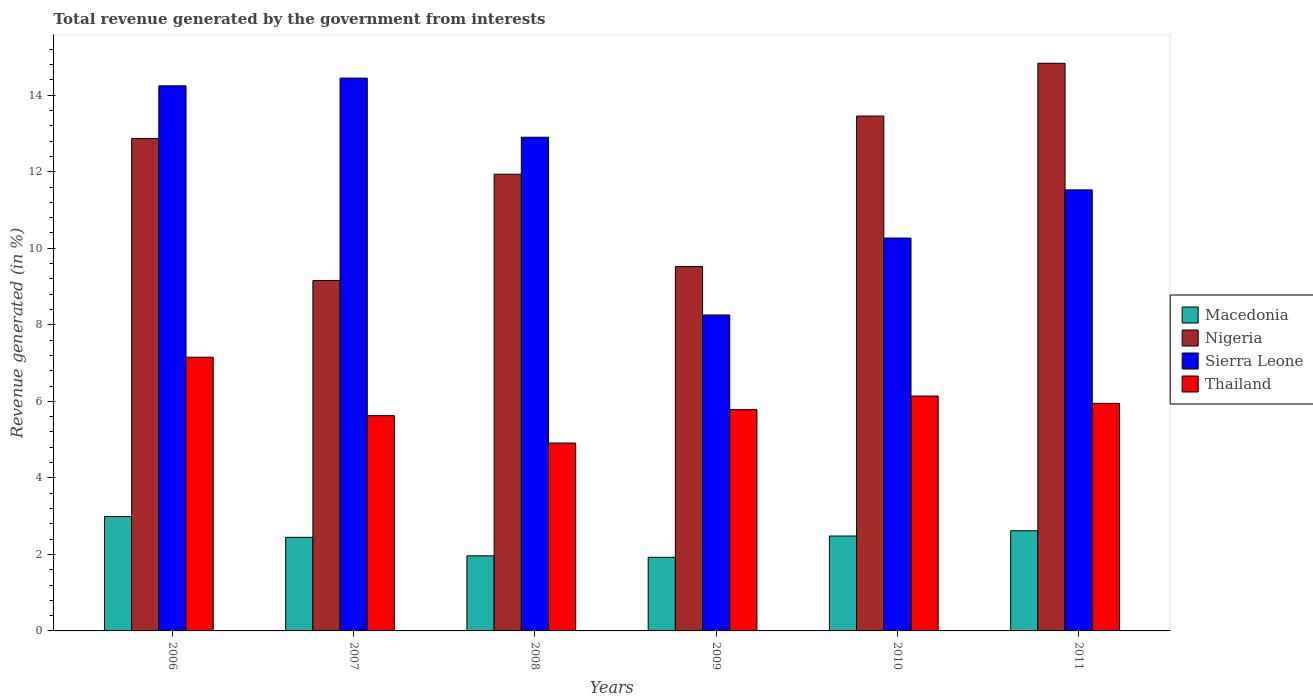How many different coloured bars are there?
Your answer should be compact. 4. Are the number of bars per tick equal to the number of legend labels?
Your answer should be compact. Yes. In how many cases, is the number of bars for a given year not equal to the number of legend labels?
Ensure brevity in your answer.  0. What is the total revenue generated in Nigeria in 2008?
Ensure brevity in your answer.  11.94. Across all years, what is the maximum total revenue generated in Nigeria?
Offer a very short reply. 14.84. Across all years, what is the minimum total revenue generated in Macedonia?
Ensure brevity in your answer.  1.92. In which year was the total revenue generated in Macedonia minimum?
Give a very brief answer. 2009. What is the total total revenue generated in Thailand in the graph?
Make the answer very short. 35.56. What is the difference between the total revenue generated in Sierra Leone in 2010 and that in 2011?
Give a very brief answer. -1.26. What is the difference between the total revenue generated in Macedonia in 2010 and the total revenue generated in Sierra Leone in 2009?
Offer a terse response. -5.78. What is the average total revenue generated in Nigeria per year?
Your response must be concise. 11.96. In the year 2011, what is the difference between the total revenue generated in Macedonia and total revenue generated in Sierra Leone?
Ensure brevity in your answer.  -8.91. What is the ratio of the total revenue generated in Macedonia in 2007 to that in 2011?
Offer a very short reply. 0.93. Is the total revenue generated in Macedonia in 2007 less than that in 2010?
Offer a very short reply. Yes. What is the difference between the highest and the second highest total revenue generated in Macedonia?
Provide a succinct answer. 0.37. What is the difference between the highest and the lowest total revenue generated in Macedonia?
Your response must be concise. 1.07. Is it the case that in every year, the sum of the total revenue generated in Thailand and total revenue generated in Nigeria is greater than the sum of total revenue generated in Sierra Leone and total revenue generated in Macedonia?
Offer a very short reply. No. What does the 4th bar from the left in 2011 represents?
Provide a short and direct response. Thailand. What does the 1st bar from the right in 2011 represents?
Offer a very short reply. Thailand. Is it the case that in every year, the sum of the total revenue generated in Macedonia and total revenue generated in Nigeria is greater than the total revenue generated in Sierra Leone?
Ensure brevity in your answer.  No. Are all the bars in the graph horizontal?
Offer a terse response. No. How many years are there in the graph?
Make the answer very short. 6. What is the difference between two consecutive major ticks on the Y-axis?
Your response must be concise. 2. Where does the legend appear in the graph?
Give a very brief answer. Center right. What is the title of the graph?
Provide a short and direct response. Total revenue generated by the government from interests. What is the label or title of the X-axis?
Give a very brief answer. Years. What is the label or title of the Y-axis?
Keep it short and to the point. Revenue generated (in %). What is the Revenue generated (in %) of Macedonia in 2006?
Your response must be concise. 2.99. What is the Revenue generated (in %) of Nigeria in 2006?
Offer a very short reply. 12.87. What is the Revenue generated (in %) of Sierra Leone in 2006?
Your answer should be compact. 14.25. What is the Revenue generated (in %) in Thailand in 2006?
Make the answer very short. 7.15. What is the Revenue generated (in %) in Macedonia in 2007?
Make the answer very short. 2.45. What is the Revenue generated (in %) of Nigeria in 2007?
Provide a succinct answer. 9.16. What is the Revenue generated (in %) of Sierra Leone in 2007?
Provide a succinct answer. 14.45. What is the Revenue generated (in %) in Thailand in 2007?
Offer a very short reply. 5.63. What is the Revenue generated (in %) of Macedonia in 2008?
Keep it short and to the point. 1.96. What is the Revenue generated (in %) of Nigeria in 2008?
Give a very brief answer. 11.94. What is the Revenue generated (in %) in Sierra Leone in 2008?
Offer a very short reply. 12.9. What is the Revenue generated (in %) in Thailand in 2008?
Make the answer very short. 4.91. What is the Revenue generated (in %) of Macedonia in 2009?
Keep it short and to the point. 1.92. What is the Revenue generated (in %) in Nigeria in 2009?
Provide a short and direct response. 9.52. What is the Revenue generated (in %) in Sierra Leone in 2009?
Provide a short and direct response. 8.26. What is the Revenue generated (in %) in Thailand in 2009?
Your answer should be very brief. 5.78. What is the Revenue generated (in %) of Macedonia in 2010?
Provide a succinct answer. 2.48. What is the Revenue generated (in %) in Nigeria in 2010?
Your answer should be compact. 13.46. What is the Revenue generated (in %) of Sierra Leone in 2010?
Your answer should be compact. 10.27. What is the Revenue generated (in %) in Thailand in 2010?
Make the answer very short. 6.14. What is the Revenue generated (in %) in Macedonia in 2011?
Give a very brief answer. 2.62. What is the Revenue generated (in %) in Nigeria in 2011?
Your answer should be compact. 14.84. What is the Revenue generated (in %) in Sierra Leone in 2011?
Your answer should be very brief. 11.53. What is the Revenue generated (in %) of Thailand in 2011?
Offer a very short reply. 5.95. Across all years, what is the maximum Revenue generated (in %) of Macedonia?
Your response must be concise. 2.99. Across all years, what is the maximum Revenue generated (in %) in Nigeria?
Your response must be concise. 14.84. Across all years, what is the maximum Revenue generated (in %) in Sierra Leone?
Give a very brief answer. 14.45. Across all years, what is the maximum Revenue generated (in %) of Thailand?
Keep it short and to the point. 7.15. Across all years, what is the minimum Revenue generated (in %) in Macedonia?
Keep it short and to the point. 1.92. Across all years, what is the minimum Revenue generated (in %) of Nigeria?
Provide a succinct answer. 9.16. Across all years, what is the minimum Revenue generated (in %) of Sierra Leone?
Keep it short and to the point. 8.26. Across all years, what is the minimum Revenue generated (in %) in Thailand?
Provide a short and direct response. 4.91. What is the total Revenue generated (in %) in Macedonia in the graph?
Your answer should be very brief. 14.42. What is the total Revenue generated (in %) of Nigeria in the graph?
Your answer should be very brief. 71.78. What is the total Revenue generated (in %) in Sierra Leone in the graph?
Offer a very short reply. 71.65. What is the total Revenue generated (in %) of Thailand in the graph?
Your answer should be compact. 35.56. What is the difference between the Revenue generated (in %) of Macedonia in 2006 and that in 2007?
Your answer should be compact. 0.54. What is the difference between the Revenue generated (in %) in Nigeria in 2006 and that in 2007?
Offer a very short reply. 3.71. What is the difference between the Revenue generated (in %) in Sierra Leone in 2006 and that in 2007?
Offer a very short reply. -0.2. What is the difference between the Revenue generated (in %) in Thailand in 2006 and that in 2007?
Ensure brevity in your answer.  1.53. What is the difference between the Revenue generated (in %) of Macedonia in 2006 and that in 2008?
Keep it short and to the point. 1.03. What is the difference between the Revenue generated (in %) of Nigeria in 2006 and that in 2008?
Give a very brief answer. 0.93. What is the difference between the Revenue generated (in %) of Sierra Leone in 2006 and that in 2008?
Make the answer very short. 1.34. What is the difference between the Revenue generated (in %) in Thailand in 2006 and that in 2008?
Provide a short and direct response. 2.24. What is the difference between the Revenue generated (in %) in Macedonia in 2006 and that in 2009?
Provide a succinct answer. 1.07. What is the difference between the Revenue generated (in %) in Nigeria in 2006 and that in 2009?
Provide a short and direct response. 3.35. What is the difference between the Revenue generated (in %) in Sierra Leone in 2006 and that in 2009?
Offer a terse response. 5.99. What is the difference between the Revenue generated (in %) of Thailand in 2006 and that in 2009?
Provide a short and direct response. 1.37. What is the difference between the Revenue generated (in %) in Macedonia in 2006 and that in 2010?
Make the answer very short. 0.51. What is the difference between the Revenue generated (in %) in Nigeria in 2006 and that in 2010?
Give a very brief answer. -0.59. What is the difference between the Revenue generated (in %) of Sierra Leone in 2006 and that in 2010?
Make the answer very short. 3.98. What is the difference between the Revenue generated (in %) in Thailand in 2006 and that in 2010?
Keep it short and to the point. 1.02. What is the difference between the Revenue generated (in %) in Macedonia in 2006 and that in 2011?
Offer a terse response. 0.37. What is the difference between the Revenue generated (in %) of Nigeria in 2006 and that in 2011?
Provide a succinct answer. -1.97. What is the difference between the Revenue generated (in %) of Sierra Leone in 2006 and that in 2011?
Offer a very short reply. 2.72. What is the difference between the Revenue generated (in %) in Thailand in 2006 and that in 2011?
Keep it short and to the point. 1.21. What is the difference between the Revenue generated (in %) of Macedonia in 2007 and that in 2008?
Give a very brief answer. 0.48. What is the difference between the Revenue generated (in %) of Nigeria in 2007 and that in 2008?
Your response must be concise. -2.78. What is the difference between the Revenue generated (in %) of Sierra Leone in 2007 and that in 2008?
Offer a terse response. 1.55. What is the difference between the Revenue generated (in %) in Thailand in 2007 and that in 2008?
Provide a succinct answer. 0.72. What is the difference between the Revenue generated (in %) of Macedonia in 2007 and that in 2009?
Give a very brief answer. 0.52. What is the difference between the Revenue generated (in %) of Nigeria in 2007 and that in 2009?
Your response must be concise. -0.37. What is the difference between the Revenue generated (in %) of Sierra Leone in 2007 and that in 2009?
Offer a terse response. 6.19. What is the difference between the Revenue generated (in %) of Thailand in 2007 and that in 2009?
Offer a terse response. -0.16. What is the difference between the Revenue generated (in %) in Macedonia in 2007 and that in 2010?
Offer a very short reply. -0.03. What is the difference between the Revenue generated (in %) of Nigeria in 2007 and that in 2010?
Make the answer very short. -4.3. What is the difference between the Revenue generated (in %) in Sierra Leone in 2007 and that in 2010?
Keep it short and to the point. 4.18. What is the difference between the Revenue generated (in %) of Thailand in 2007 and that in 2010?
Provide a short and direct response. -0.51. What is the difference between the Revenue generated (in %) in Macedonia in 2007 and that in 2011?
Ensure brevity in your answer.  -0.17. What is the difference between the Revenue generated (in %) in Nigeria in 2007 and that in 2011?
Offer a very short reply. -5.68. What is the difference between the Revenue generated (in %) in Sierra Leone in 2007 and that in 2011?
Make the answer very short. 2.92. What is the difference between the Revenue generated (in %) in Thailand in 2007 and that in 2011?
Provide a succinct answer. -0.32. What is the difference between the Revenue generated (in %) of Macedonia in 2008 and that in 2009?
Offer a very short reply. 0.04. What is the difference between the Revenue generated (in %) of Nigeria in 2008 and that in 2009?
Your response must be concise. 2.41. What is the difference between the Revenue generated (in %) of Sierra Leone in 2008 and that in 2009?
Ensure brevity in your answer.  4.65. What is the difference between the Revenue generated (in %) in Thailand in 2008 and that in 2009?
Your answer should be compact. -0.87. What is the difference between the Revenue generated (in %) in Macedonia in 2008 and that in 2010?
Ensure brevity in your answer.  -0.52. What is the difference between the Revenue generated (in %) of Nigeria in 2008 and that in 2010?
Provide a short and direct response. -1.52. What is the difference between the Revenue generated (in %) of Sierra Leone in 2008 and that in 2010?
Make the answer very short. 2.63. What is the difference between the Revenue generated (in %) of Thailand in 2008 and that in 2010?
Keep it short and to the point. -1.23. What is the difference between the Revenue generated (in %) of Macedonia in 2008 and that in 2011?
Your answer should be compact. -0.66. What is the difference between the Revenue generated (in %) of Nigeria in 2008 and that in 2011?
Your answer should be compact. -2.9. What is the difference between the Revenue generated (in %) in Sierra Leone in 2008 and that in 2011?
Ensure brevity in your answer.  1.38. What is the difference between the Revenue generated (in %) of Thailand in 2008 and that in 2011?
Provide a succinct answer. -1.04. What is the difference between the Revenue generated (in %) of Macedonia in 2009 and that in 2010?
Make the answer very short. -0.56. What is the difference between the Revenue generated (in %) of Nigeria in 2009 and that in 2010?
Ensure brevity in your answer.  -3.93. What is the difference between the Revenue generated (in %) in Sierra Leone in 2009 and that in 2010?
Keep it short and to the point. -2.01. What is the difference between the Revenue generated (in %) of Thailand in 2009 and that in 2010?
Your answer should be very brief. -0.36. What is the difference between the Revenue generated (in %) in Macedonia in 2009 and that in 2011?
Give a very brief answer. -0.69. What is the difference between the Revenue generated (in %) of Nigeria in 2009 and that in 2011?
Your answer should be compact. -5.31. What is the difference between the Revenue generated (in %) of Sierra Leone in 2009 and that in 2011?
Provide a succinct answer. -3.27. What is the difference between the Revenue generated (in %) of Thailand in 2009 and that in 2011?
Keep it short and to the point. -0.17. What is the difference between the Revenue generated (in %) in Macedonia in 2010 and that in 2011?
Make the answer very short. -0.14. What is the difference between the Revenue generated (in %) in Nigeria in 2010 and that in 2011?
Make the answer very short. -1.38. What is the difference between the Revenue generated (in %) of Sierra Leone in 2010 and that in 2011?
Your response must be concise. -1.26. What is the difference between the Revenue generated (in %) of Thailand in 2010 and that in 2011?
Ensure brevity in your answer.  0.19. What is the difference between the Revenue generated (in %) of Macedonia in 2006 and the Revenue generated (in %) of Nigeria in 2007?
Provide a short and direct response. -6.17. What is the difference between the Revenue generated (in %) of Macedonia in 2006 and the Revenue generated (in %) of Sierra Leone in 2007?
Your answer should be compact. -11.46. What is the difference between the Revenue generated (in %) of Macedonia in 2006 and the Revenue generated (in %) of Thailand in 2007?
Keep it short and to the point. -2.64. What is the difference between the Revenue generated (in %) in Nigeria in 2006 and the Revenue generated (in %) in Sierra Leone in 2007?
Offer a very short reply. -1.58. What is the difference between the Revenue generated (in %) of Nigeria in 2006 and the Revenue generated (in %) of Thailand in 2007?
Ensure brevity in your answer.  7.24. What is the difference between the Revenue generated (in %) in Sierra Leone in 2006 and the Revenue generated (in %) in Thailand in 2007?
Keep it short and to the point. 8.62. What is the difference between the Revenue generated (in %) in Macedonia in 2006 and the Revenue generated (in %) in Nigeria in 2008?
Offer a very short reply. -8.95. What is the difference between the Revenue generated (in %) in Macedonia in 2006 and the Revenue generated (in %) in Sierra Leone in 2008?
Ensure brevity in your answer.  -9.91. What is the difference between the Revenue generated (in %) of Macedonia in 2006 and the Revenue generated (in %) of Thailand in 2008?
Make the answer very short. -1.92. What is the difference between the Revenue generated (in %) of Nigeria in 2006 and the Revenue generated (in %) of Sierra Leone in 2008?
Make the answer very short. -0.03. What is the difference between the Revenue generated (in %) of Nigeria in 2006 and the Revenue generated (in %) of Thailand in 2008?
Offer a very short reply. 7.96. What is the difference between the Revenue generated (in %) of Sierra Leone in 2006 and the Revenue generated (in %) of Thailand in 2008?
Ensure brevity in your answer.  9.34. What is the difference between the Revenue generated (in %) of Macedonia in 2006 and the Revenue generated (in %) of Nigeria in 2009?
Your answer should be very brief. -6.53. What is the difference between the Revenue generated (in %) in Macedonia in 2006 and the Revenue generated (in %) in Sierra Leone in 2009?
Offer a very short reply. -5.27. What is the difference between the Revenue generated (in %) of Macedonia in 2006 and the Revenue generated (in %) of Thailand in 2009?
Ensure brevity in your answer.  -2.79. What is the difference between the Revenue generated (in %) in Nigeria in 2006 and the Revenue generated (in %) in Sierra Leone in 2009?
Offer a very short reply. 4.61. What is the difference between the Revenue generated (in %) in Nigeria in 2006 and the Revenue generated (in %) in Thailand in 2009?
Provide a short and direct response. 7.09. What is the difference between the Revenue generated (in %) in Sierra Leone in 2006 and the Revenue generated (in %) in Thailand in 2009?
Provide a short and direct response. 8.46. What is the difference between the Revenue generated (in %) of Macedonia in 2006 and the Revenue generated (in %) of Nigeria in 2010?
Give a very brief answer. -10.47. What is the difference between the Revenue generated (in %) in Macedonia in 2006 and the Revenue generated (in %) in Sierra Leone in 2010?
Ensure brevity in your answer.  -7.28. What is the difference between the Revenue generated (in %) of Macedonia in 2006 and the Revenue generated (in %) of Thailand in 2010?
Provide a short and direct response. -3.15. What is the difference between the Revenue generated (in %) in Nigeria in 2006 and the Revenue generated (in %) in Sierra Leone in 2010?
Provide a succinct answer. 2.6. What is the difference between the Revenue generated (in %) in Nigeria in 2006 and the Revenue generated (in %) in Thailand in 2010?
Your response must be concise. 6.73. What is the difference between the Revenue generated (in %) in Sierra Leone in 2006 and the Revenue generated (in %) in Thailand in 2010?
Provide a succinct answer. 8.11. What is the difference between the Revenue generated (in %) in Macedonia in 2006 and the Revenue generated (in %) in Nigeria in 2011?
Provide a succinct answer. -11.85. What is the difference between the Revenue generated (in %) of Macedonia in 2006 and the Revenue generated (in %) of Sierra Leone in 2011?
Provide a short and direct response. -8.54. What is the difference between the Revenue generated (in %) of Macedonia in 2006 and the Revenue generated (in %) of Thailand in 2011?
Ensure brevity in your answer.  -2.96. What is the difference between the Revenue generated (in %) in Nigeria in 2006 and the Revenue generated (in %) in Sierra Leone in 2011?
Offer a very short reply. 1.34. What is the difference between the Revenue generated (in %) in Nigeria in 2006 and the Revenue generated (in %) in Thailand in 2011?
Offer a terse response. 6.92. What is the difference between the Revenue generated (in %) of Sierra Leone in 2006 and the Revenue generated (in %) of Thailand in 2011?
Ensure brevity in your answer.  8.3. What is the difference between the Revenue generated (in %) in Macedonia in 2007 and the Revenue generated (in %) in Nigeria in 2008?
Ensure brevity in your answer.  -9.49. What is the difference between the Revenue generated (in %) in Macedonia in 2007 and the Revenue generated (in %) in Sierra Leone in 2008?
Ensure brevity in your answer.  -10.46. What is the difference between the Revenue generated (in %) in Macedonia in 2007 and the Revenue generated (in %) in Thailand in 2008?
Provide a succinct answer. -2.46. What is the difference between the Revenue generated (in %) of Nigeria in 2007 and the Revenue generated (in %) of Sierra Leone in 2008?
Provide a succinct answer. -3.75. What is the difference between the Revenue generated (in %) of Nigeria in 2007 and the Revenue generated (in %) of Thailand in 2008?
Your answer should be compact. 4.25. What is the difference between the Revenue generated (in %) in Sierra Leone in 2007 and the Revenue generated (in %) in Thailand in 2008?
Provide a short and direct response. 9.54. What is the difference between the Revenue generated (in %) of Macedonia in 2007 and the Revenue generated (in %) of Nigeria in 2009?
Ensure brevity in your answer.  -7.08. What is the difference between the Revenue generated (in %) of Macedonia in 2007 and the Revenue generated (in %) of Sierra Leone in 2009?
Keep it short and to the point. -5.81. What is the difference between the Revenue generated (in %) of Macedonia in 2007 and the Revenue generated (in %) of Thailand in 2009?
Offer a terse response. -3.34. What is the difference between the Revenue generated (in %) in Nigeria in 2007 and the Revenue generated (in %) in Sierra Leone in 2009?
Keep it short and to the point. 0.9. What is the difference between the Revenue generated (in %) in Nigeria in 2007 and the Revenue generated (in %) in Thailand in 2009?
Your answer should be compact. 3.37. What is the difference between the Revenue generated (in %) of Sierra Leone in 2007 and the Revenue generated (in %) of Thailand in 2009?
Make the answer very short. 8.67. What is the difference between the Revenue generated (in %) in Macedonia in 2007 and the Revenue generated (in %) in Nigeria in 2010?
Your answer should be very brief. -11.01. What is the difference between the Revenue generated (in %) of Macedonia in 2007 and the Revenue generated (in %) of Sierra Leone in 2010?
Ensure brevity in your answer.  -7.82. What is the difference between the Revenue generated (in %) of Macedonia in 2007 and the Revenue generated (in %) of Thailand in 2010?
Your response must be concise. -3.69. What is the difference between the Revenue generated (in %) in Nigeria in 2007 and the Revenue generated (in %) in Sierra Leone in 2010?
Ensure brevity in your answer.  -1.11. What is the difference between the Revenue generated (in %) of Nigeria in 2007 and the Revenue generated (in %) of Thailand in 2010?
Provide a succinct answer. 3.02. What is the difference between the Revenue generated (in %) of Sierra Leone in 2007 and the Revenue generated (in %) of Thailand in 2010?
Provide a succinct answer. 8.31. What is the difference between the Revenue generated (in %) in Macedonia in 2007 and the Revenue generated (in %) in Nigeria in 2011?
Offer a terse response. -12.39. What is the difference between the Revenue generated (in %) of Macedonia in 2007 and the Revenue generated (in %) of Sierra Leone in 2011?
Offer a very short reply. -9.08. What is the difference between the Revenue generated (in %) in Macedonia in 2007 and the Revenue generated (in %) in Thailand in 2011?
Keep it short and to the point. -3.5. What is the difference between the Revenue generated (in %) of Nigeria in 2007 and the Revenue generated (in %) of Sierra Leone in 2011?
Your response must be concise. -2.37. What is the difference between the Revenue generated (in %) of Nigeria in 2007 and the Revenue generated (in %) of Thailand in 2011?
Provide a short and direct response. 3.21. What is the difference between the Revenue generated (in %) of Sierra Leone in 2007 and the Revenue generated (in %) of Thailand in 2011?
Give a very brief answer. 8.5. What is the difference between the Revenue generated (in %) of Macedonia in 2008 and the Revenue generated (in %) of Nigeria in 2009?
Ensure brevity in your answer.  -7.56. What is the difference between the Revenue generated (in %) of Macedonia in 2008 and the Revenue generated (in %) of Sierra Leone in 2009?
Give a very brief answer. -6.29. What is the difference between the Revenue generated (in %) of Macedonia in 2008 and the Revenue generated (in %) of Thailand in 2009?
Give a very brief answer. -3.82. What is the difference between the Revenue generated (in %) of Nigeria in 2008 and the Revenue generated (in %) of Sierra Leone in 2009?
Ensure brevity in your answer.  3.68. What is the difference between the Revenue generated (in %) of Nigeria in 2008 and the Revenue generated (in %) of Thailand in 2009?
Your response must be concise. 6.15. What is the difference between the Revenue generated (in %) in Sierra Leone in 2008 and the Revenue generated (in %) in Thailand in 2009?
Give a very brief answer. 7.12. What is the difference between the Revenue generated (in %) of Macedonia in 2008 and the Revenue generated (in %) of Nigeria in 2010?
Provide a short and direct response. -11.49. What is the difference between the Revenue generated (in %) of Macedonia in 2008 and the Revenue generated (in %) of Sierra Leone in 2010?
Offer a very short reply. -8.31. What is the difference between the Revenue generated (in %) of Macedonia in 2008 and the Revenue generated (in %) of Thailand in 2010?
Give a very brief answer. -4.18. What is the difference between the Revenue generated (in %) in Nigeria in 2008 and the Revenue generated (in %) in Sierra Leone in 2010?
Provide a short and direct response. 1.67. What is the difference between the Revenue generated (in %) in Nigeria in 2008 and the Revenue generated (in %) in Thailand in 2010?
Provide a succinct answer. 5.8. What is the difference between the Revenue generated (in %) of Sierra Leone in 2008 and the Revenue generated (in %) of Thailand in 2010?
Provide a succinct answer. 6.76. What is the difference between the Revenue generated (in %) of Macedonia in 2008 and the Revenue generated (in %) of Nigeria in 2011?
Make the answer very short. -12.87. What is the difference between the Revenue generated (in %) of Macedonia in 2008 and the Revenue generated (in %) of Sierra Leone in 2011?
Provide a short and direct response. -9.56. What is the difference between the Revenue generated (in %) of Macedonia in 2008 and the Revenue generated (in %) of Thailand in 2011?
Keep it short and to the point. -3.98. What is the difference between the Revenue generated (in %) of Nigeria in 2008 and the Revenue generated (in %) of Sierra Leone in 2011?
Your response must be concise. 0.41. What is the difference between the Revenue generated (in %) of Nigeria in 2008 and the Revenue generated (in %) of Thailand in 2011?
Offer a terse response. 5.99. What is the difference between the Revenue generated (in %) in Sierra Leone in 2008 and the Revenue generated (in %) in Thailand in 2011?
Ensure brevity in your answer.  6.96. What is the difference between the Revenue generated (in %) in Macedonia in 2009 and the Revenue generated (in %) in Nigeria in 2010?
Provide a succinct answer. -11.53. What is the difference between the Revenue generated (in %) in Macedonia in 2009 and the Revenue generated (in %) in Sierra Leone in 2010?
Give a very brief answer. -8.34. What is the difference between the Revenue generated (in %) in Macedonia in 2009 and the Revenue generated (in %) in Thailand in 2010?
Offer a terse response. -4.21. What is the difference between the Revenue generated (in %) in Nigeria in 2009 and the Revenue generated (in %) in Sierra Leone in 2010?
Provide a succinct answer. -0.74. What is the difference between the Revenue generated (in %) in Nigeria in 2009 and the Revenue generated (in %) in Thailand in 2010?
Your answer should be compact. 3.39. What is the difference between the Revenue generated (in %) in Sierra Leone in 2009 and the Revenue generated (in %) in Thailand in 2010?
Keep it short and to the point. 2.12. What is the difference between the Revenue generated (in %) of Macedonia in 2009 and the Revenue generated (in %) of Nigeria in 2011?
Offer a very short reply. -12.91. What is the difference between the Revenue generated (in %) in Macedonia in 2009 and the Revenue generated (in %) in Sierra Leone in 2011?
Offer a very short reply. -9.6. What is the difference between the Revenue generated (in %) in Macedonia in 2009 and the Revenue generated (in %) in Thailand in 2011?
Your answer should be compact. -4.02. What is the difference between the Revenue generated (in %) of Nigeria in 2009 and the Revenue generated (in %) of Sierra Leone in 2011?
Your answer should be very brief. -2. What is the difference between the Revenue generated (in %) in Nigeria in 2009 and the Revenue generated (in %) in Thailand in 2011?
Keep it short and to the point. 3.58. What is the difference between the Revenue generated (in %) of Sierra Leone in 2009 and the Revenue generated (in %) of Thailand in 2011?
Provide a succinct answer. 2.31. What is the difference between the Revenue generated (in %) in Macedonia in 2010 and the Revenue generated (in %) in Nigeria in 2011?
Offer a terse response. -12.36. What is the difference between the Revenue generated (in %) of Macedonia in 2010 and the Revenue generated (in %) of Sierra Leone in 2011?
Offer a terse response. -9.05. What is the difference between the Revenue generated (in %) in Macedonia in 2010 and the Revenue generated (in %) in Thailand in 2011?
Offer a very short reply. -3.47. What is the difference between the Revenue generated (in %) of Nigeria in 2010 and the Revenue generated (in %) of Sierra Leone in 2011?
Ensure brevity in your answer.  1.93. What is the difference between the Revenue generated (in %) of Nigeria in 2010 and the Revenue generated (in %) of Thailand in 2011?
Your response must be concise. 7.51. What is the difference between the Revenue generated (in %) in Sierra Leone in 2010 and the Revenue generated (in %) in Thailand in 2011?
Keep it short and to the point. 4.32. What is the average Revenue generated (in %) in Macedonia per year?
Give a very brief answer. 2.4. What is the average Revenue generated (in %) of Nigeria per year?
Give a very brief answer. 11.96. What is the average Revenue generated (in %) in Sierra Leone per year?
Provide a succinct answer. 11.94. What is the average Revenue generated (in %) of Thailand per year?
Keep it short and to the point. 5.93. In the year 2006, what is the difference between the Revenue generated (in %) in Macedonia and Revenue generated (in %) in Nigeria?
Provide a short and direct response. -9.88. In the year 2006, what is the difference between the Revenue generated (in %) of Macedonia and Revenue generated (in %) of Sierra Leone?
Offer a terse response. -11.26. In the year 2006, what is the difference between the Revenue generated (in %) in Macedonia and Revenue generated (in %) in Thailand?
Give a very brief answer. -4.16. In the year 2006, what is the difference between the Revenue generated (in %) in Nigeria and Revenue generated (in %) in Sierra Leone?
Provide a succinct answer. -1.38. In the year 2006, what is the difference between the Revenue generated (in %) in Nigeria and Revenue generated (in %) in Thailand?
Ensure brevity in your answer.  5.72. In the year 2006, what is the difference between the Revenue generated (in %) of Sierra Leone and Revenue generated (in %) of Thailand?
Provide a short and direct response. 7.09. In the year 2007, what is the difference between the Revenue generated (in %) of Macedonia and Revenue generated (in %) of Nigeria?
Ensure brevity in your answer.  -6.71. In the year 2007, what is the difference between the Revenue generated (in %) in Macedonia and Revenue generated (in %) in Sierra Leone?
Give a very brief answer. -12. In the year 2007, what is the difference between the Revenue generated (in %) of Macedonia and Revenue generated (in %) of Thailand?
Ensure brevity in your answer.  -3.18. In the year 2007, what is the difference between the Revenue generated (in %) in Nigeria and Revenue generated (in %) in Sierra Leone?
Ensure brevity in your answer.  -5.29. In the year 2007, what is the difference between the Revenue generated (in %) in Nigeria and Revenue generated (in %) in Thailand?
Keep it short and to the point. 3.53. In the year 2007, what is the difference between the Revenue generated (in %) of Sierra Leone and Revenue generated (in %) of Thailand?
Your answer should be compact. 8.82. In the year 2008, what is the difference between the Revenue generated (in %) of Macedonia and Revenue generated (in %) of Nigeria?
Your response must be concise. -9.97. In the year 2008, what is the difference between the Revenue generated (in %) of Macedonia and Revenue generated (in %) of Sierra Leone?
Ensure brevity in your answer.  -10.94. In the year 2008, what is the difference between the Revenue generated (in %) of Macedonia and Revenue generated (in %) of Thailand?
Provide a short and direct response. -2.95. In the year 2008, what is the difference between the Revenue generated (in %) in Nigeria and Revenue generated (in %) in Sierra Leone?
Your answer should be compact. -0.97. In the year 2008, what is the difference between the Revenue generated (in %) in Nigeria and Revenue generated (in %) in Thailand?
Give a very brief answer. 7.03. In the year 2008, what is the difference between the Revenue generated (in %) in Sierra Leone and Revenue generated (in %) in Thailand?
Keep it short and to the point. 7.99. In the year 2009, what is the difference between the Revenue generated (in %) in Macedonia and Revenue generated (in %) in Nigeria?
Provide a succinct answer. -7.6. In the year 2009, what is the difference between the Revenue generated (in %) of Macedonia and Revenue generated (in %) of Sierra Leone?
Offer a very short reply. -6.33. In the year 2009, what is the difference between the Revenue generated (in %) in Macedonia and Revenue generated (in %) in Thailand?
Your answer should be very brief. -3.86. In the year 2009, what is the difference between the Revenue generated (in %) of Nigeria and Revenue generated (in %) of Sierra Leone?
Provide a succinct answer. 1.27. In the year 2009, what is the difference between the Revenue generated (in %) in Nigeria and Revenue generated (in %) in Thailand?
Provide a succinct answer. 3.74. In the year 2009, what is the difference between the Revenue generated (in %) in Sierra Leone and Revenue generated (in %) in Thailand?
Give a very brief answer. 2.47. In the year 2010, what is the difference between the Revenue generated (in %) in Macedonia and Revenue generated (in %) in Nigeria?
Offer a very short reply. -10.98. In the year 2010, what is the difference between the Revenue generated (in %) in Macedonia and Revenue generated (in %) in Sierra Leone?
Your answer should be compact. -7.79. In the year 2010, what is the difference between the Revenue generated (in %) in Macedonia and Revenue generated (in %) in Thailand?
Provide a succinct answer. -3.66. In the year 2010, what is the difference between the Revenue generated (in %) of Nigeria and Revenue generated (in %) of Sierra Leone?
Your answer should be very brief. 3.19. In the year 2010, what is the difference between the Revenue generated (in %) in Nigeria and Revenue generated (in %) in Thailand?
Provide a short and direct response. 7.32. In the year 2010, what is the difference between the Revenue generated (in %) in Sierra Leone and Revenue generated (in %) in Thailand?
Make the answer very short. 4.13. In the year 2011, what is the difference between the Revenue generated (in %) of Macedonia and Revenue generated (in %) of Nigeria?
Your answer should be very brief. -12.22. In the year 2011, what is the difference between the Revenue generated (in %) in Macedonia and Revenue generated (in %) in Sierra Leone?
Offer a very short reply. -8.91. In the year 2011, what is the difference between the Revenue generated (in %) in Macedonia and Revenue generated (in %) in Thailand?
Provide a short and direct response. -3.33. In the year 2011, what is the difference between the Revenue generated (in %) of Nigeria and Revenue generated (in %) of Sierra Leone?
Your answer should be compact. 3.31. In the year 2011, what is the difference between the Revenue generated (in %) of Nigeria and Revenue generated (in %) of Thailand?
Ensure brevity in your answer.  8.89. In the year 2011, what is the difference between the Revenue generated (in %) in Sierra Leone and Revenue generated (in %) in Thailand?
Provide a succinct answer. 5.58. What is the ratio of the Revenue generated (in %) in Macedonia in 2006 to that in 2007?
Ensure brevity in your answer.  1.22. What is the ratio of the Revenue generated (in %) of Nigeria in 2006 to that in 2007?
Your answer should be compact. 1.41. What is the ratio of the Revenue generated (in %) in Sierra Leone in 2006 to that in 2007?
Provide a short and direct response. 0.99. What is the ratio of the Revenue generated (in %) of Thailand in 2006 to that in 2007?
Provide a short and direct response. 1.27. What is the ratio of the Revenue generated (in %) of Macedonia in 2006 to that in 2008?
Your answer should be compact. 1.52. What is the ratio of the Revenue generated (in %) of Nigeria in 2006 to that in 2008?
Offer a terse response. 1.08. What is the ratio of the Revenue generated (in %) in Sierra Leone in 2006 to that in 2008?
Your response must be concise. 1.1. What is the ratio of the Revenue generated (in %) of Thailand in 2006 to that in 2008?
Keep it short and to the point. 1.46. What is the ratio of the Revenue generated (in %) in Macedonia in 2006 to that in 2009?
Offer a terse response. 1.55. What is the ratio of the Revenue generated (in %) of Nigeria in 2006 to that in 2009?
Your answer should be compact. 1.35. What is the ratio of the Revenue generated (in %) of Sierra Leone in 2006 to that in 2009?
Keep it short and to the point. 1.73. What is the ratio of the Revenue generated (in %) of Thailand in 2006 to that in 2009?
Your answer should be very brief. 1.24. What is the ratio of the Revenue generated (in %) of Macedonia in 2006 to that in 2010?
Your answer should be compact. 1.21. What is the ratio of the Revenue generated (in %) in Nigeria in 2006 to that in 2010?
Give a very brief answer. 0.96. What is the ratio of the Revenue generated (in %) of Sierra Leone in 2006 to that in 2010?
Ensure brevity in your answer.  1.39. What is the ratio of the Revenue generated (in %) of Thailand in 2006 to that in 2010?
Your answer should be very brief. 1.17. What is the ratio of the Revenue generated (in %) in Macedonia in 2006 to that in 2011?
Offer a very short reply. 1.14. What is the ratio of the Revenue generated (in %) of Nigeria in 2006 to that in 2011?
Provide a short and direct response. 0.87. What is the ratio of the Revenue generated (in %) of Sierra Leone in 2006 to that in 2011?
Make the answer very short. 1.24. What is the ratio of the Revenue generated (in %) of Thailand in 2006 to that in 2011?
Keep it short and to the point. 1.2. What is the ratio of the Revenue generated (in %) of Macedonia in 2007 to that in 2008?
Your answer should be very brief. 1.25. What is the ratio of the Revenue generated (in %) of Nigeria in 2007 to that in 2008?
Give a very brief answer. 0.77. What is the ratio of the Revenue generated (in %) of Sierra Leone in 2007 to that in 2008?
Offer a terse response. 1.12. What is the ratio of the Revenue generated (in %) in Thailand in 2007 to that in 2008?
Your answer should be compact. 1.15. What is the ratio of the Revenue generated (in %) of Macedonia in 2007 to that in 2009?
Provide a short and direct response. 1.27. What is the ratio of the Revenue generated (in %) in Nigeria in 2007 to that in 2009?
Your answer should be very brief. 0.96. What is the ratio of the Revenue generated (in %) in Sierra Leone in 2007 to that in 2009?
Provide a succinct answer. 1.75. What is the ratio of the Revenue generated (in %) of Thailand in 2007 to that in 2009?
Your response must be concise. 0.97. What is the ratio of the Revenue generated (in %) of Macedonia in 2007 to that in 2010?
Your answer should be compact. 0.99. What is the ratio of the Revenue generated (in %) of Nigeria in 2007 to that in 2010?
Offer a very short reply. 0.68. What is the ratio of the Revenue generated (in %) of Sierra Leone in 2007 to that in 2010?
Keep it short and to the point. 1.41. What is the ratio of the Revenue generated (in %) in Thailand in 2007 to that in 2010?
Give a very brief answer. 0.92. What is the ratio of the Revenue generated (in %) of Macedonia in 2007 to that in 2011?
Ensure brevity in your answer.  0.93. What is the ratio of the Revenue generated (in %) of Nigeria in 2007 to that in 2011?
Your response must be concise. 0.62. What is the ratio of the Revenue generated (in %) in Sierra Leone in 2007 to that in 2011?
Ensure brevity in your answer.  1.25. What is the ratio of the Revenue generated (in %) of Thailand in 2007 to that in 2011?
Your answer should be compact. 0.95. What is the ratio of the Revenue generated (in %) in Macedonia in 2008 to that in 2009?
Offer a very short reply. 1.02. What is the ratio of the Revenue generated (in %) of Nigeria in 2008 to that in 2009?
Ensure brevity in your answer.  1.25. What is the ratio of the Revenue generated (in %) of Sierra Leone in 2008 to that in 2009?
Provide a succinct answer. 1.56. What is the ratio of the Revenue generated (in %) of Thailand in 2008 to that in 2009?
Your answer should be very brief. 0.85. What is the ratio of the Revenue generated (in %) in Macedonia in 2008 to that in 2010?
Provide a short and direct response. 0.79. What is the ratio of the Revenue generated (in %) in Nigeria in 2008 to that in 2010?
Your answer should be compact. 0.89. What is the ratio of the Revenue generated (in %) of Sierra Leone in 2008 to that in 2010?
Provide a succinct answer. 1.26. What is the ratio of the Revenue generated (in %) in Macedonia in 2008 to that in 2011?
Keep it short and to the point. 0.75. What is the ratio of the Revenue generated (in %) in Nigeria in 2008 to that in 2011?
Make the answer very short. 0.8. What is the ratio of the Revenue generated (in %) of Sierra Leone in 2008 to that in 2011?
Your answer should be compact. 1.12. What is the ratio of the Revenue generated (in %) of Thailand in 2008 to that in 2011?
Give a very brief answer. 0.83. What is the ratio of the Revenue generated (in %) of Macedonia in 2009 to that in 2010?
Provide a succinct answer. 0.78. What is the ratio of the Revenue generated (in %) in Nigeria in 2009 to that in 2010?
Ensure brevity in your answer.  0.71. What is the ratio of the Revenue generated (in %) of Sierra Leone in 2009 to that in 2010?
Keep it short and to the point. 0.8. What is the ratio of the Revenue generated (in %) in Thailand in 2009 to that in 2010?
Ensure brevity in your answer.  0.94. What is the ratio of the Revenue generated (in %) in Macedonia in 2009 to that in 2011?
Offer a very short reply. 0.73. What is the ratio of the Revenue generated (in %) in Nigeria in 2009 to that in 2011?
Make the answer very short. 0.64. What is the ratio of the Revenue generated (in %) of Sierra Leone in 2009 to that in 2011?
Provide a succinct answer. 0.72. What is the ratio of the Revenue generated (in %) of Thailand in 2009 to that in 2011?
Give a very brief answer. 0.97. What is the ratio of the Revenue generated (in %) of Macedonia in 2010 to that in 2011?
Your answer should be very brief. 0.95. What is the ratio of the Revenue generated (in %) of Nigeria in 2010 to that in 2011?
Offer a terse response. 0.91. What is the ratio of the Revenue generated (in %) of Sierra Leone in 2010 to that in 2011?
Ensure brevity in your answer.  0.89. What is the ratio of the Revenue generated (in %) in Thailand in 2010 to that in 2011?
Keep it short and to the point. 1.03. What is the difference between the highest and the second highest Revenue generated (in %) in Macedonia?
Your answer should be very brief. 0.37. What is the difference between the highest and the second highest Revenue generated (in %) of Nigeria?
Your answer should be compact. 1.38. What is the difference between the highest and the second highest Revenue generated (in %) of Sierra Leone?
Provide a short and direct response. 0.2. What is the difference between the highest and the second highest Revenue generated (in %) of Thailand?
Offer a very short reply. 1.02. What is the difference between the highest and the lowest Revenue generated (in %) in Macedonia?
Your answer should be very brief. 1.07. What is the difference between the highest and the lowest Revenue generated (in %) of Nigeria?
Keep it short and to the point. 5.68. What is the difference between the highest and the lowest Revenue generated (in %) of Sierra Leone?
Provide a short and direct response. 6.19. What is the difference between the highest and the lowest Revenue generated (in %) of Thailand?
Offer a very short reply. 2.24. 